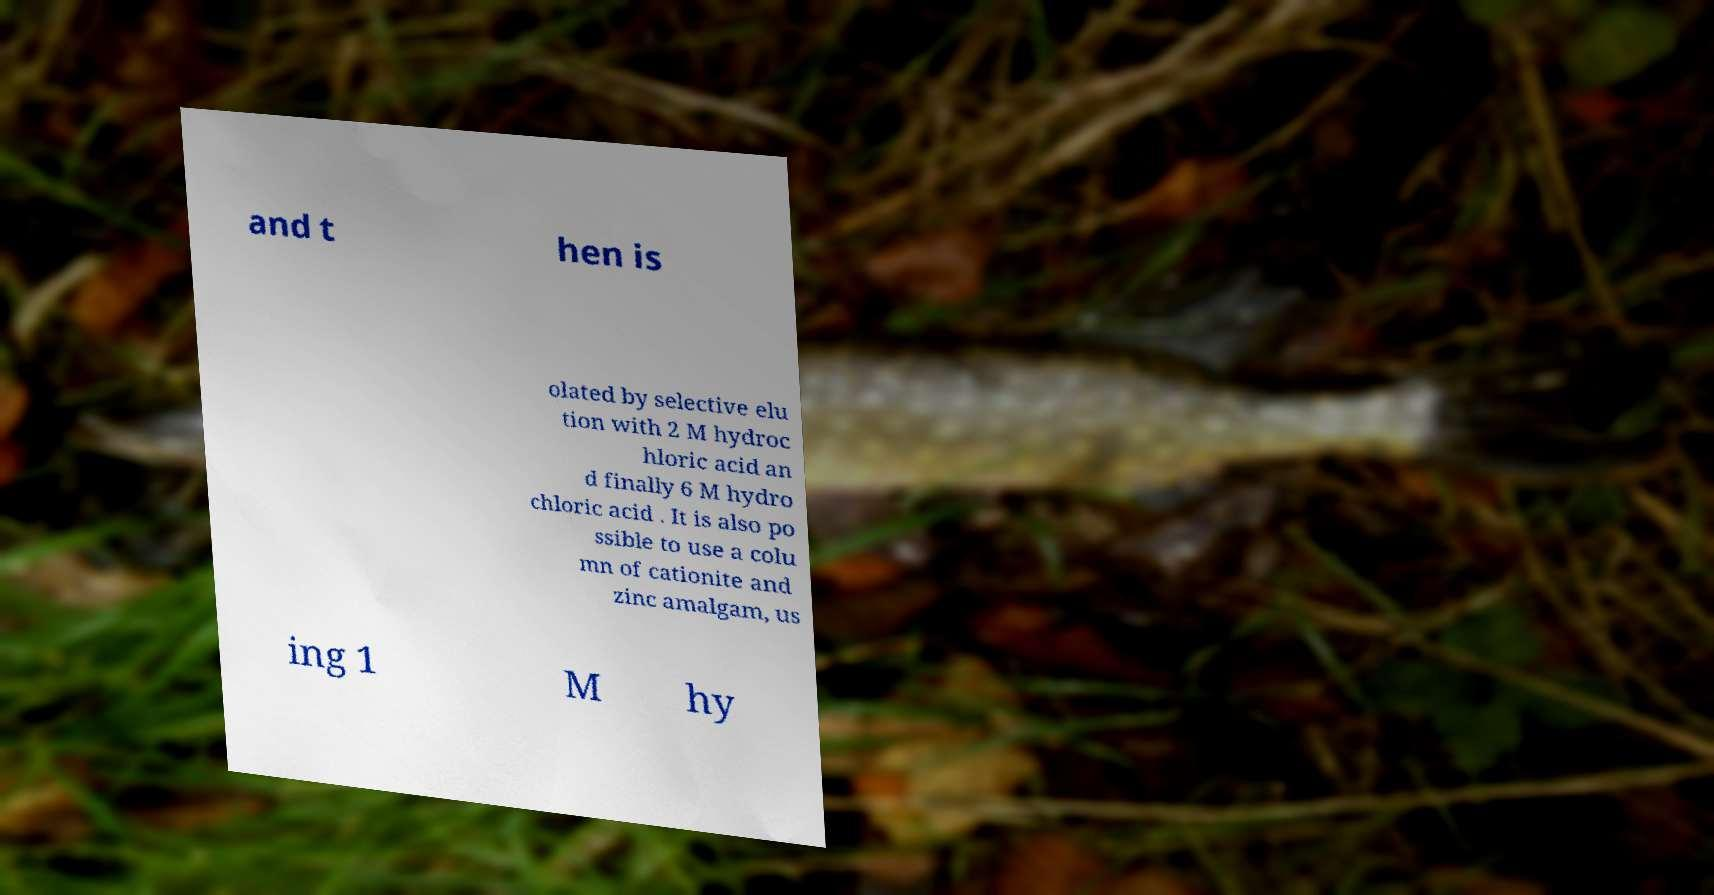Can you read and provide the text displayed in the image?This photo seems to have some interesting text. Can you extract and type it out for me? and t hen is olated by selective elu tion with 2 M hydroc hloric acid an d finally 6 M hydro chloric acid . It is also po ssible to use a colu mn of cationite and zinc amalgam, us ing 1 M hy 